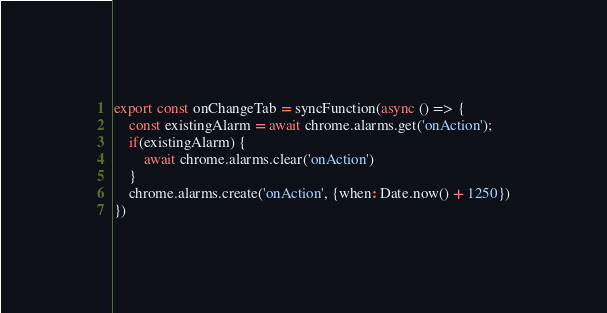<code> <loc_0><loc_0><loc_500><loc_500><_JavaScript_>

export const onChangeTab = syncFunction(async () => {
	const existingAlarm = await chrome.alarms.get('onAction');
	if(existingAlarm) {
		await chrome.alarms.clear('onAction')
	}
	chrome.alarms.create('onAction', {when: Date.now() + 1250})
})
</code> 